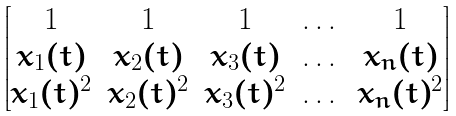Convert formula to latex. <formula><loc_0><loc_0><loc_500><loc_500>\begin{bmatrix} 1 & 1 & 1 & \dots & 1 \\ x _ { 1 } ( t ) & x _ { 2 } ( t ) & x _ { 3 } ( t ) & \dots & x _ { n } ( t ) \\ x _ { 1 } ( t ) ^ { 2 } & x _ { 2 } ( t ) ^ { 2 } & x _ { 3 } ( t ) ^ { 2 } & \dots & x _ { n } ( t ) ^ { 2 } \end{bmatrix}</formula> 